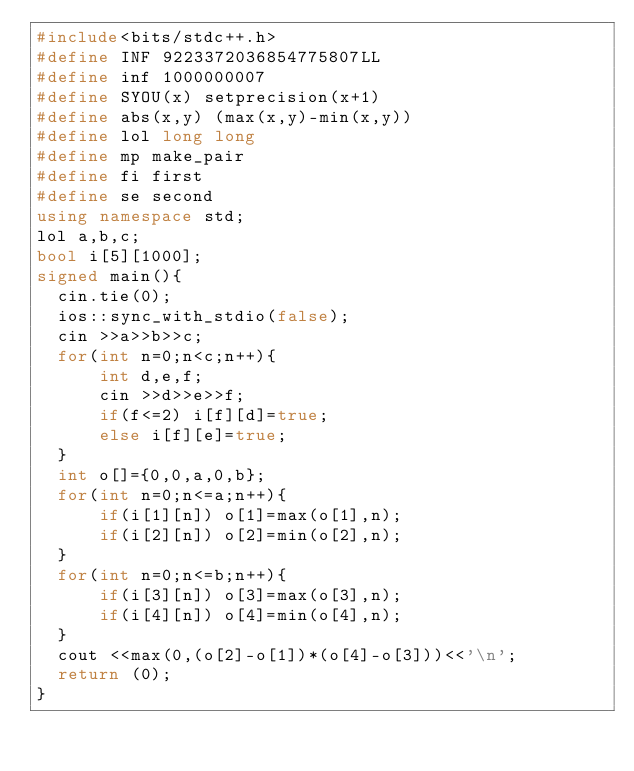Convert code to text. <code><loc_0><loc_0><loc_500><loc_500><_C++_>#include<bits/stdc++.h>
#define INF 9223372036854775807LL
#define inf 1000000007
#define SYOU(x) setprecision(x+1)
#define abs(x,y) (max(x,y)-min(x,y))
#define lol long long
#define mp make_pair
#define fi first
#define se second
using namespace std;
lol a,b,c;
bool i[5][1000];
signed main(){
  cin.tie(0);
  ios::sync_with_stdio(false);
  cin >>a>>b>>c;
  for(int n=0;n<c;n++){
      int d,e,f;
      cin >>d>>e>>f;
      if(f<=2) i[f][d]=true;
      else i[f][e]=true;
  }
  int o[]={0,0,a,0,b};
  for(int n=0;n<=a;n++){
      if(i[1][n]) o[1]=max(o[1],n);
      if(i[2][n]) o[2]=min(o[2],n);
  }
  for(int n=0;n<=b;n++){
      if(i[3][n]) o[3]=max(o[3],n);
      if(i[4][n]) o[4]=min(o[4],n);
  }
  cout <<max(0,(o[2]-o[1])*(o[4]-o[3]))<<'\n';  
  return (0);
}
</code> 